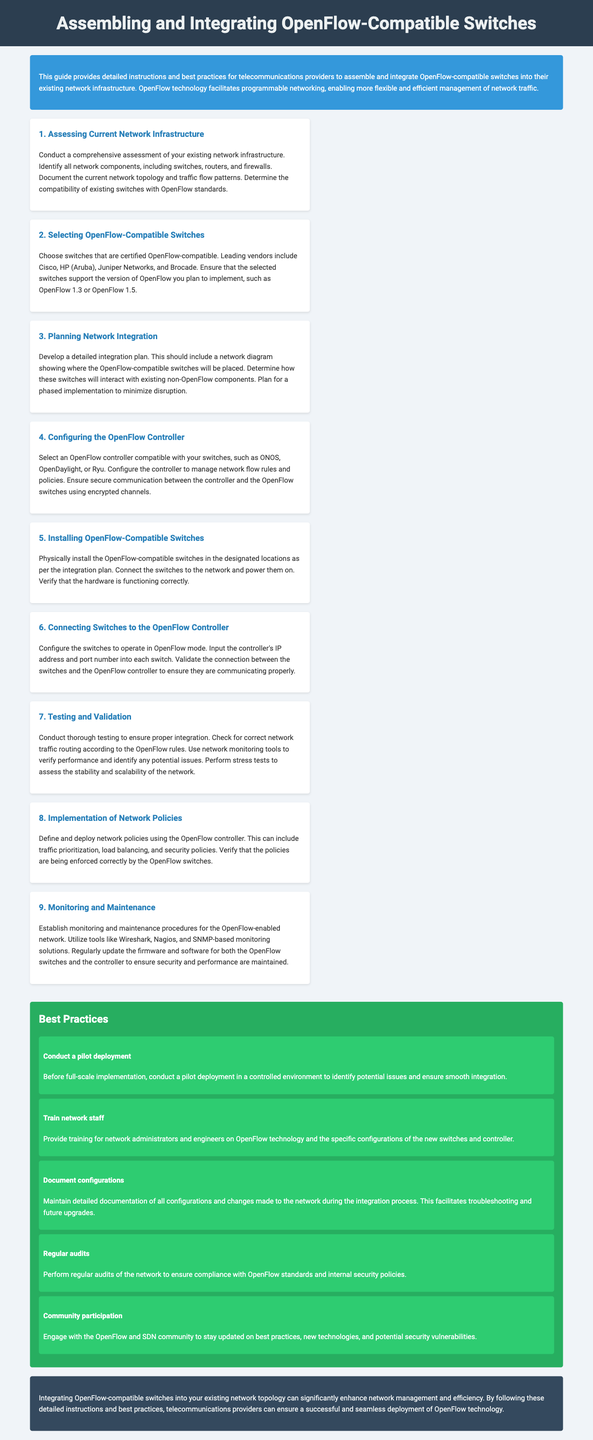1. What is the first step in the integration process? The first step is to conduct a comprehensive assessment of your existing network infrastructure.
Answer: Assessing Current Network Infrastructure 2. Which vendors are recommended for OpenFlow-compatible switches? The document lists leading vendors as Cisco, HP (Aruba), Juniper Networks, and Brocade.
Answer: Cisco, HP (Aruba), Juniper Networks, Brocade 3. What should be developed before integrating OpenFlow switches? A detailed integration plan should be developed, including a network diagram.
Answer: Detailed integration plan 4. What is the purpose of testing and validation? The purpose is to ensure proper integration and check for correct network traffic routing according to OpenFlow rules.
Answer: Ensure proper integration 5. How often should firmware and software be updated? Regularly update the firmware and software to maintain security and performance.
Answer: Regularly 6. What is a best practice before full-scale implementation? Conduct a pilot deployment in a controlled environment to identify potential issues.
Answer: Conduct a pilot deployment 7. Which tools can be used for network monitoring? The document mentions Wireshark, Nagios, and SNMP-based monitoring solutions.
Answer: Wireshark, Nagios, SNMP-based monitoring solutions 8. What should be maintained during the integration process? Detailed documentation of all configurations and changes made to the network should be maintained.
Answer: Detailed documentation 9. What is the last section of the document about? The last section provides a conclusion about the benefits of integrating OpenFlow switches.
Answer: Conclusion 10. What should be ensured during the connection between the controller and switches? Ensure secure communication between the controller and the OpenFlow switches using encrypted channels.
Answer: Secure communication 